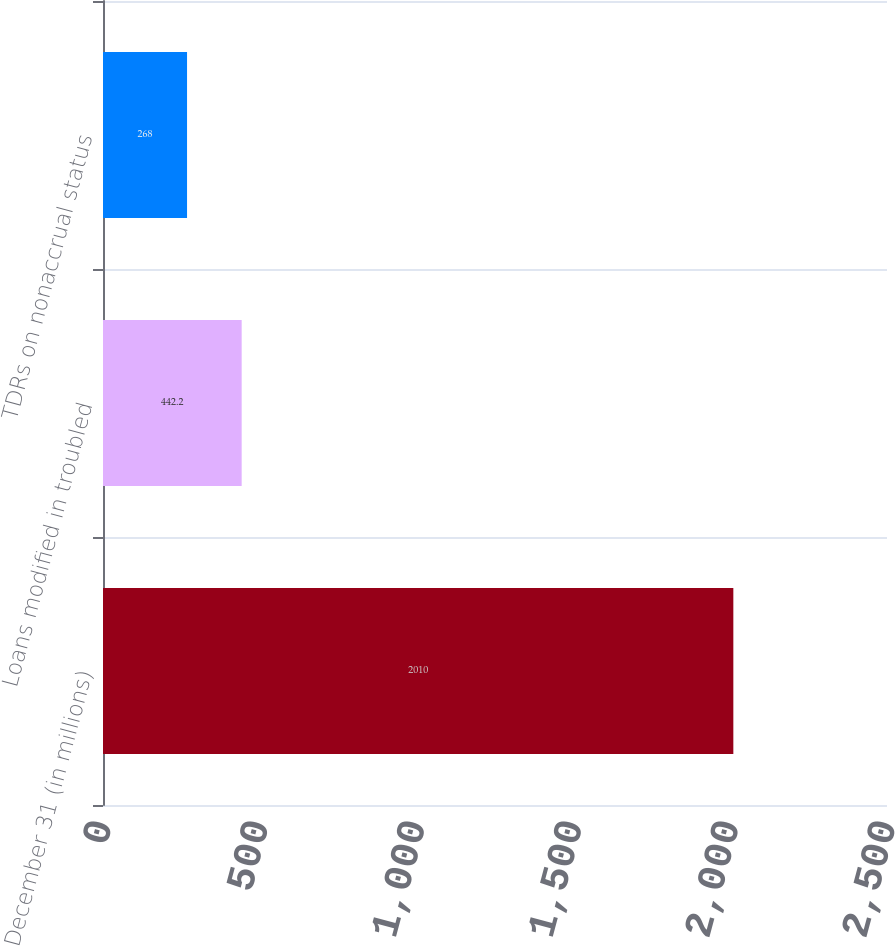Convert chart to OTSL. <chart><loc_0><loc_0><loc_500><loc_500><bar_chart><fcel>December 31 (in millions)<fcel>Loans modified in troubled<fcel>TDRs on nonaccrual status<nl><fcel>2010<fcel>442.2<fcel>268<nl></chart> 